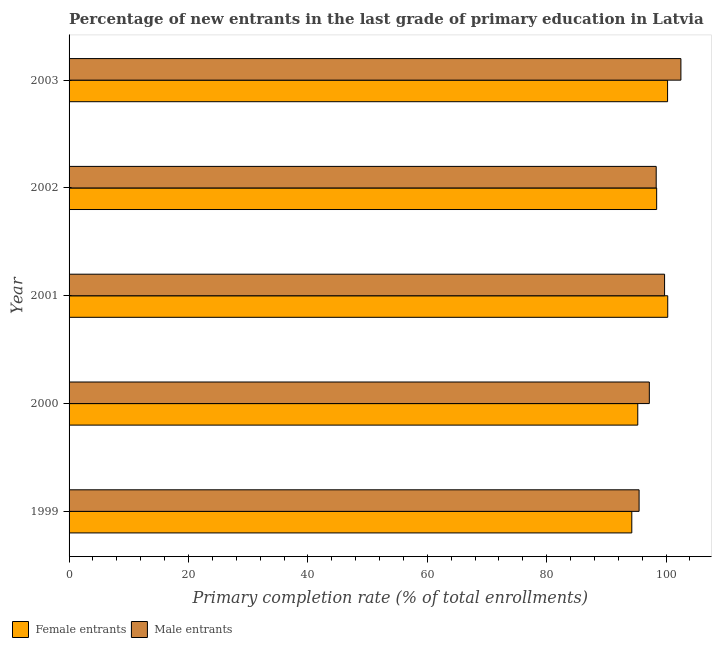How many groups of bars are there?
Your answer should be very brief. 5. Are the number of bars on each tick of the Y-axis equal?
Give a very brief answer. Yes. What is the primary completion rate of male entrants in 2002?
Provide a succinct answer. 98.34. Across all years, what is the maximum primary completion rate of male entrants?
Keep it short and to the point. 102.48. Across all years, what is the minimum primary completion rate of female entrants?
Your answer should be very brief. 94.25. In which year was the primary completion rate of male entrants minimum?
Ensure brevity in your answer.  1999. What is the total primary completion rate of female entrants in the graph?
Your response must be concise. 488.45. What is the difference between the primary completion rate of female entrants in 1999 and that in 2002?
Provide a succinct answer. -4.17. What is the difference between the primary completion rate of male entrants in 2000 and the primary completion rate of female entrants in 1999?
Your answer should be very brief. 2.94. What is the average primary completion rate of female entrants per year?
Provide a short and direct response. 97.69. In the year 2002, what is the difference between the primary completion rate of male entrants and primary completion rate of female entrants?
Offer a terse response. -0.08. In how many years, is the primary completion rate of female entrants greater than 44 %?
Keep it short and to the point. 5. Is the primary completion rate of male entrants in 2001 less than that in 2002?
Offer a terse response. No. What is the difference between the highest and the second highest primary completion rate of female entrants?
Make the answer very short. 0.03. In how many years, is the primary completion rate of female entrants greater than the average primary completion rate of female entrants taken over all years?
Make the answer very short. 3. Is the sum of the primary completion rate of male entrants in 2002 and 2003 greater than the maximum primary completion rate of female entrants across all years?
Your response must be concise. Yes. What does the 1st bar from the top in 2001 represents?
Your answer should be compact. Male entrants. What does the 2nd bar from the bottom in 1999 represents?
Your response must be concise. Male entrants. How many bars are there?
Offer a terse response. 10. How many years are there in the graph?
Provide a succinct answer. 5. Does the graph contain any zero values?
Provide a succinct answer. No. How many legend labels are there?
Give a very brief answer. 2. How are the legend labels stacked?
Make the answer very short. Horizontal. What is the title of the graph?
Make the answer very short. Percentage of new entrants in the last grade of primary education in Latvia. What is the label or title of the X-axis?
Your response must be concise. Primary completion rate (% of total enrollments). What is the label or title of the Y-axis?
Ensure brevity in your answer.  Year. What is the Primary completion rate (% of total enrollments) of Female entrants in 1999?
Keep it short and to the point. 94.25. What is the Primary completion rate (% of total enrollments) of Male entrants in 1999?
Keep it short and to the point. 95.48. What is the Primary completion rate (% of total enrollments) of Female entrants in 2000?
Your answer should be very brief. 95.25. What is the Primary completion rate (% of total enrollments) of Male entrants in 2000?
Offer a very short reply. 97.19. What is the Primary completion rate (% of total enrollments) in Female entrants in 2001?
Give a very brief answer. 100.27. What is the Primary completion rate (% of total enrollments) in Male entrants in 2001?
Give a very brief answer. 99.74. What is the Primary completion rate (% of total enrollments) in Female entrants in 2002?
Provide a succinct answer. 98.42. What is the Primary completion rate (% of total enrollments) of Male entrants in 2002?
Your answer should be very brief. 98.34. What is the Primary completion rate (% of total enrollments) of Female entrants in 2003?
Provide a succinct answer. 100.25. What is the Primary completion rate (% of total enrollments) of Male entrants in 2003?
Offer a terse response. 102.48. Across all years, what is the maximum Primary completion rate (% of total enrollments) in Female entrants?
Provide a succinct answer. 100.27. Across all years, what is the maximum Primary completion rate (% of total enrollments) of Male entrants?
Offer a very short reply. 102.48. Across all years, what is the minimum Primary completion rate (% of total enrollments) of Female entrants?
Provide a short and direct response. 94.25. Across all years, what is the minimum Primary completion rate (% of total enrollments) in Male entrants?
Offer a very short reply. 95.48. What is the total Primary completion rate (% of total enrollments) of Female entrants in the graph?
Your response must be concise. 488.45. What is the total Primary completion rate (% of total enrollments) of Male entrants in the graph?
Provide a short and direct response. 493.23. What is the difference between the Primary completion rate (% of total enrollments) in Female entrants in 1999 and that in 2000?
Provide a short and direct response. -1. What is the difference between the Primary completion rate (% of total enrollments) in Male entrants in 1999 and that in 2000?
Give a very brief answer. -1.71. What is the difference between the Primary completion rate (% of total enrollments) in Female entrants in 1999 and that in 2001?
Offer a terse response. -6.02. What is the difference between the Primary completion rate (% of total enrollments) in Male entrants in 1999 and that in 2001?
Give a very brief answer. -4.27. What is the difference between the Primary completion rate (% of total enrollments) of Female entrants in 1999 and that in 2002?
Your response must be concise. -4.17. What is the difference between the Primary completion rate (% of total enrollments) in Male entrants in 1999 and that in 2002?
Make the answer very short. -2.86. What is the difference between the Primary completion rate (% of total enrollments) of Female entrants in 1999 and that in 2003?
Your answer should be compact. -5.99. What is the difference between the Primary completion rate (% of total enrollments) of Male entrants in 1999 and that in 2003?
Your response must be concise. -7. What is the difference between the Primary completion rate (% of total enrollments) of Female entrants in 2000 and that in 2001?
Offer a terse response. -5.02. What is the difference between the Primary completion rate (% of total enrollments) in Male entrants in 2000 and that in 2001?
Ensure brevity in your answer.  -2.55. What is the difference between the Primary completion rate (% of total enrollments) of Female entrants in 2000 and that in 2002?
Your response must be concise. -3.17. What is the difference between the Primary completion rate (% of total enrollments) of Male entrants in 2000 and that in 2002?
Offer a very short reply. -1.15. What is the difference between the Primary completion rate (% of total enrollments) of Female entrants in 2000 and that in 2003?
Provide a short and direct response. -4.99. What is the difference between the Primary completion rate (% of total enrollments) of Male entrants in 2000 and that in 2003?
Keep it short and to the point. -5.29. What is the difference between the Primary completion rate (% of total enrollments) of Female entrants in 2001 and that in 2002?
Offer a very short reply. 1.85. What is the difference between the Primary completion rate (% of total enrollments) in Male entrants in 2001 and that in 2002?
Give a very brief answer. 1.4. What is the difference between the Primary completion rate (% of total enrollments) of Female entrants in 2001 and that in 2003?
Your answer should be very brief. 0.03. What is the difference between the Primary completion rate (% of total enrollments) of Male entrants in 2001 and that in 2003?
Your answer should be very brief. -2.74. What is the difference between the Primary completion rate (% of total enrollments) of Female entrants in 2002 and that in 2003?
Ensure brevity in your answer.  -1.83. What is the difference between the Primary completion rate (% of total enrollments) in Male entrants in 2002 and that in 2003?
Offer a very short reply. -4.14. What is the difference between the Primary completion rate (% of total enrollments) in Female entrants in 1999 and the Primary completion rate (% of total enrollments) in Male entrants in 2000?
Your answer should be compact. -2.94. What is the difference between the Primary completion rate (% of total enrollments) in Female entrants in 1999 and the Primary completion rate (% of total enrollments) in Male entrants in 2001?
Your response must be concise. -5.49. What is the difference between the Primary completion rate (% of total enrollments) of Female entrants in 1999 and the Primary completion rate (% of total enrollments) of Male entrants in 2002?
Make the answer very short. -4.09. What is the difference between the Primary completion rate (% of total enrollments) in Female entrants in 1999 and the Primary completion rate (% of total enrollments) in Male entrants in 2003?
Offer a terse response. -8.23. What is the difference between the Primary completion rate (% of total enrollments) in Female entrants in 2000 and the Primary completion rate (% of total enrollments) in Male entrants in 2001?
Your answer should be compact. -4.49. What is the difference between the Primary completion rate (% of total enrollments) in Female entrants in 2000 and the Primary completion rate (% of total enrollments) in Male entrants in 2002?
Offer a terse response. -3.09. What is the difference between the Primary completion rate (% of total enrollments) in Female entrants in 2000 and the Primary completion rate (% of total enrollments) in Male entrants in 2003?
Your response must be concise. -7.23. What is the difference between the Primary completion rate (% of total enrollments) of Female entrants in 2001 and the Primary completion rate (% of total enrollments) of Male entrants in 2002?
Offer a terse response. 1.93. What is the difference between the Primary completion rate (% of total enrollments) of Female entrants in 2001 and the Primary completion rate (% of total enrollments) of Male entrants in 2003?
Provide a succinct answer. -2.21. What is the difference between the Primary completion rate (% of total enrollments) of Female entrants in 2002 and the Primary completion rate (% of total enrollments) of Male entrants in 2003?
Keep it short and to the point. -4.06. What is the average Primary completion rate (% of total enrollments) in Female entrants per year?
Give a very brief answer. 97.69. What is the average Primary completion rate (% of total enrollments) in Male entrants per year?
Offer a very short reply. 98.65. In the year 1999, what is the difference between the Primary completion rate (% of total enrollments) of Female entrants and Primary completion rate (% of total enrollments) of Male entrants?
Provide a short and direct response. -1.22. In the year 2000, what is the difference between the Primary completion rate (% of total enrollments) in Female entrants and Primary completion rate (% of total enrollments) in Male entrants?
Provide a succinct answer. -1.94. In the year 2001, what is the difference between the Primary completion rate (% of total enrollments) in Female entrants and Primary completion rate (% of total enrollments) in Male entrants?
Keep it short and to the point. 0.53. In the year 2002, what is the difference between the Primary completion rate (% of total enrollments) of Female entrants and Primary completion rate (% of total enrollments) of Male entrants?
Provide a succinct answer. 0.08. In the year 2003, what is the difference between the Primary completion rate (% of total enrollments) in Female entrants and Primary completion rate (% of total enrollments) in Male entrants?
Your answer should be very brief. -2.23. What is the ratio of the Primary completion rate (% of total enrollments) in Female entrants in 1999 to that in 2000?
Give a very brief answer. 0.99. What is the ratio of the Primary completion rate (% of total enrollments) in Male entrants in 1999 to that in 2000?
Offer a terse response. 0.98. What is the ratio of the Primary completion rate (% of total enrollments) of Male entrants in 1999 to that in 2001?
Provide a succinct answer. 0.96. What is the ratio of the Primary completion rate (% of total enrollments) in Female entrants in 1999 to that in 2002?
Offer a terse response. 0.96. What is the ratio of the Primary completion rate (% of total enrollments) of Male entrants in 1999 to that in 2002?
Ensure brevity in your answer.  0.97. What is the ratio of the Primary completion rate (% of total enrollments) in Female entrants in 1999 to that in 2003?
Give a very brief answer. 0.94. What is the ratio of the Primary completion rate (% of total enrollments) in Male entrants in 1999 to that in 2003?
Provide a short and direct response. 0.93. What is the ratio of the Primary completion rate (% of total enrollments) in Female entrants in 2000 to that in 2001?
Provide a succinct answer. 0.95. What is the ratio of the Primary completion rate (% of total enrollments) of Male entrants in 2000 to that in 2001?
Your answer should be very brief. 0.97. What is the ratio of the Primary completion rate (% of total enrollments) of Female entrants in 2000 to that in 2002?
Your answer should be very brief. 0.97. What is the ratio of the Primary completion rate (% of total enrollments) of Male entrants in 2000 to that in 2002?
Provide a succinct answer. 0.99. What is the ratio of the Primary completion rate (% of total enrollments) in Female entrants in 2000 to that in 2003?
Offer a terse response. 0.95. What is the ratio of the Primary completion rate (% of total enrollments) in Male entrants in 2000 to that in 2003?
Give a very brief answer. 0.95. What is the ratio of the Primary completion rate (% of total enrollments) of Female entrants in 2001 to that in 2002?
Your answer should be compact. 1.02. What is the ratio of the Primary completion rate (% of total enrollments) of Male entrants in 2001 to that in 2002?
Keep it short and to the point. 1.01. What is the ratio of the Primary completion rate (% of total enrollments) of Female entrants in 2001 to that in 2003?
Provide a succinct answer. 1. What is the ratio of the Primary completion rate (% of total enrollments) of Male entrants in 2001 to that in 2003?
Keep it short and to the point. 0.97. What is the ratio of the Primary completion rate (% of total enrollments) of Female entrants in 2002 to that in 2003?
Make the answer very short. 0.98. What is the ratio of the Primary completion rate (% of total enrollments) of Male entrants in 2002 to that in 2003?
Ensure brevity in your answer.  0.96. What is the difference between the highest and the second highest Primary completion rate (% of total enrollments) of Female entrants?
Offer a very short reply. 0.03. What is the difference between the highest and the second highest Primary completion rate (% of total enrollments) of Male entrants?
Ensure brevity in your answer.  2.74. What is the difference between the highest and the lowest Primary completion rate (% of total enrollments) of Female entrants?
Make the answer very short. 6.02. What is the difference between the highest and the lowest Primary completion rate (% of total enrollments) in Male entrants?
Ensure brevity in your answer.  7. 